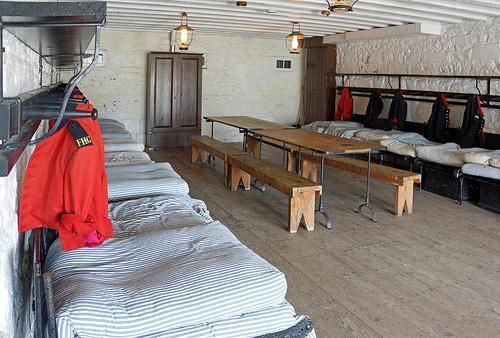How many black jackets are hanging on the right side of the image?
Give a very brief answer. 4. 